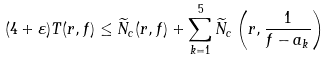Convert formula to latex. <formula><loc_0><loc_0><loc_500><loc_500>( 4 + \varepsilon ) T ( r , f ) \leq \widetilde { N } _ { c } ( r , f ) + \sum _ { k = 1 } ^ { 5 } \widetilde { N } _ { c } \left ( r , \frac { 1 } { f - a _ { k } } \right )</formula> 